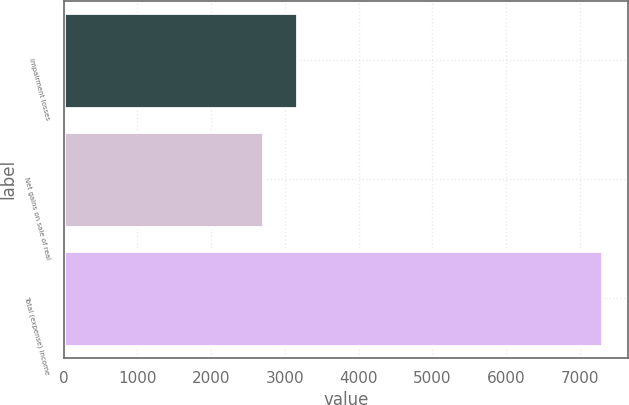Convert chart. <chart><loc_0><loc_0><loc_500><loc_500><bar_chart><fcel>Impairment losses<fcel>Net gains on sale of real<fcel>Total (expense) income<nl><fcel>3164.3<fcel>2705<fcel>7298<nl></chart> 